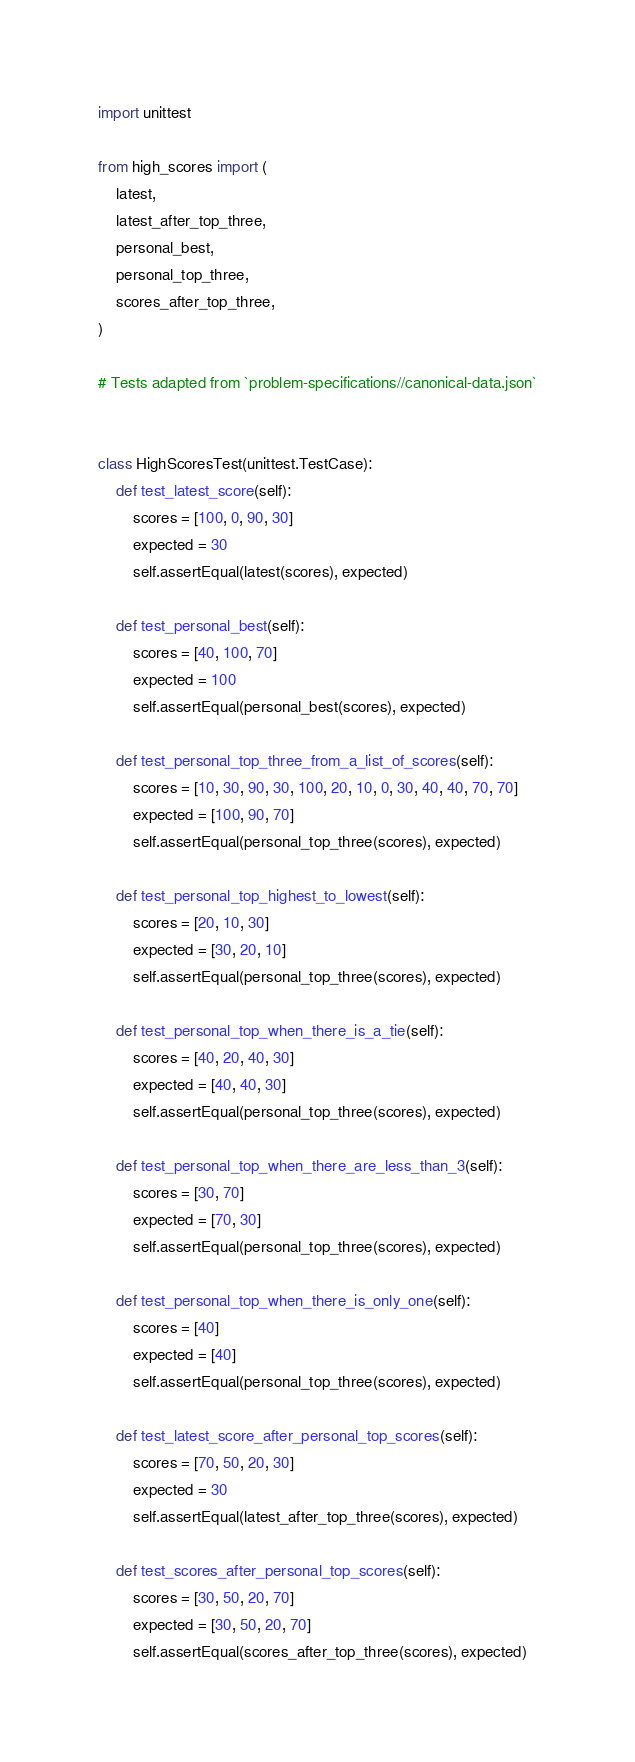Convert code to text. <code><loc_0><loc_0><loc_500><loc_500><_Python_>import unittest

from high_scores import (
    latest,
    latest_after_top_three,
    personal_best,
    personal_top_three,
    scores_after_top_three,
)

# Tests adapted from `problem-specifications//canonical-data.json`


class HighScoresTest(unittest.TestCase):
    def test_latest_score(self):
        scores = [100, 0, 90, 30]
        expected = 30
        self.assertEqual(latest(scores), expected)

    def test_personal_best(self):
        scores = [40, 100, 70]
        expected = 100
        self.assertEqual(personal_best(scores), expected)

    def test_personal_top_three_from_a_list_of_scores(self):
        scores = [10, 30, 90, 30, 100, 20, 10, 0, 30, 40, 40, 70, 70]
        expected = [100, 90, 70]
        self.assertEqual(personal_top_three(scores), expected)

    def test_personal_top_highest_to_lowest(self):
        scores = [20, 10, 30]
        expected = [30, 20, 10]
        self.assertEqual(personal_top_three(scores), expected)

    def test_personal_top_when_there_is_a_tie(self):
        scores = [40, 20, 40, 30]
        expected = [40, 40, 30]
        self.assertEqual(personal_top_three(scores), expected)

    def test_personal_top_when_there_are_less_than_3(self):
        scores = [30, 70]
        expected = [70, 30]
        self.assertEqual(personal_top_three(scores), expected)

    def test_personal_top_when_there_is_only_one(self):
        scores = [40]
        expected = [40]
        self.assertEqual(personal_top_three(scores), expected)

    def test_latest_score_after_personal_top_scores(self):
        scores = [70, 50, 20, 30]
        expected = 30
        self.assertEqual(latest_after_top_three(scores), expected)

    def test_scores_after_personal_top_scores(self):
        scores = [30, 50, 20, 70]
        expected = [30, 50, 20, 70]
        self.assertEqual(scores_after_top_three(scores), expected)
</code> 